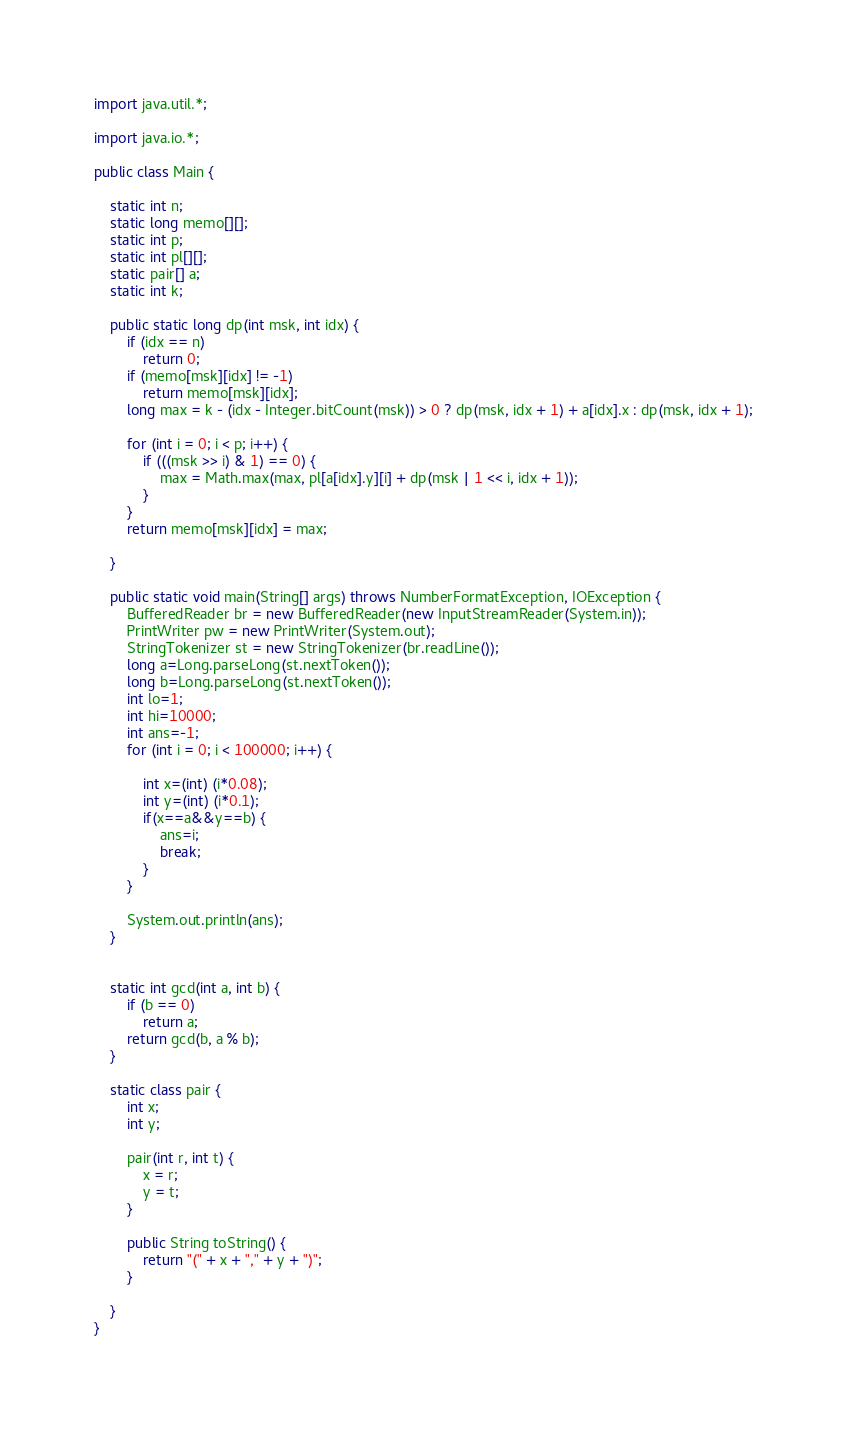Convert code to text. <code><loc_0><loc_0><loc_500><loc_500><_Java_>import java.util.*;

import java.io.*;

public class Main {

	static int n;
	static long memo[][];
	static int p;
	static int pl[][];
	static pair[] a;
	static int k;

	public static long dp(int msk, int idx) {
		if (idx == n)
			return 0;
		if (memo[msk][idx] != -1)
			return memo[msk][idx];
		long max = k - (idx - Integer.bitCount(msk)) > 0 ? dp(msk, idx + 1) + a[idx].x : dp(msk, idx + 1);

		for (int i = 0; i < p; i++) {
			if (((msk >> i) & 1) == 0) {
				max = Math.max(max, pl[a[idx].y][i] + dp(msk | 1 << i, idx + 1));
			}
		}
		return memo[msk][idx] = max;

	}

	public static void main(String[] args) throws NumberFormatException, IOException {
		BufferedReader br = new BufferedReader(new InputStreamReader(System.in));
		PrintWriter pw = new PrintWriter(System.out);
		StringTokenizer st = new StringTokenizer(br.readLine());
		long a=Long.parseLong(st.nextToken());
		long b=Long.parseLong(st.nextToken());
		int lo=1;
		int hi=10000;
		int ans=-1;
		for (int i = 0; i < 100000; i++) {
			
			int x=(int) (i*0.08);
			int y=(int) (i*0.1);
			if(x==a&&y==b) {
				ans=i;
				break;
			}
		}
		
		System.out.println(ans);
	}
	

	static int gcd(int a, int b) {
		if (b == 0)
			return a;
		return gcd(b, a % b);
	}

	static class pair {
		int x;
		int y;

		pair(int r, int t) {
			x = r;
			y = t;
		}

		public String toString() {
			return "(" + x + "," + y + ")";
		}

	}
}</code> 